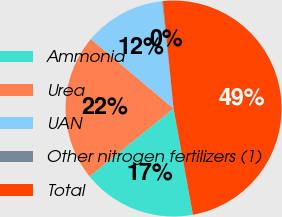Convert chart to OTSL. <chart><loc_0><loc_0><loc_500><loc_500><pie_chart><fcel>Ammonia<fcel>Urea<fcel>UAN<fcel>Other nitrogen fertilizers (1)<fcel>Total<nl><fcel>17.06%<fcel>21.92%<fcel>12.2%<fcel>0.11%<fcel>48.7%<nl></chart> 